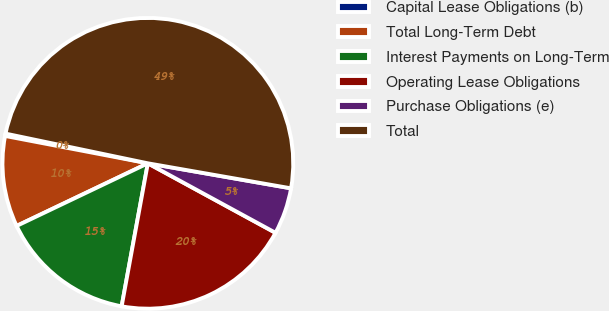Convert chart to OTSL. <chart><loc_0><loc_0><loc_500><loc_500><pie_chart><fcel>Capital Lease Obligations (b)<fcel>Total Long-Term Debt<fcel>Interest Payments on Long-Term<fcel>Operating Lease Obligations<fcel>Purchase Obligations (e)<fcel>Total<nl><fcel>0.26%<fcel>10.1%<fcel>15.03%<fcel>19.95%<fcel>5.18%<fcel>49.48%<nl></chart> 